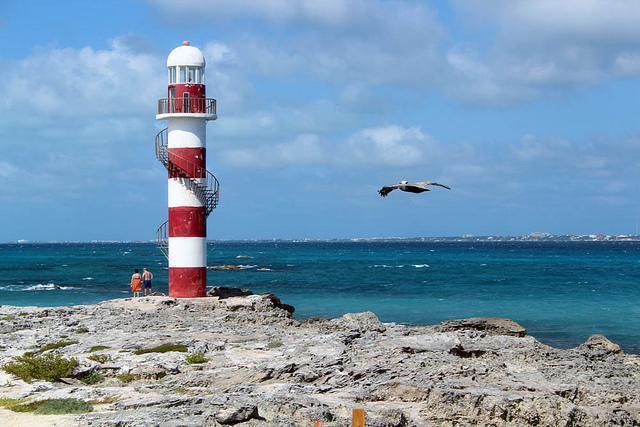How many people are there?
Give a very brief answer. 2. How many colorful umbrellas are there?
Give a very brief answer. 0. 